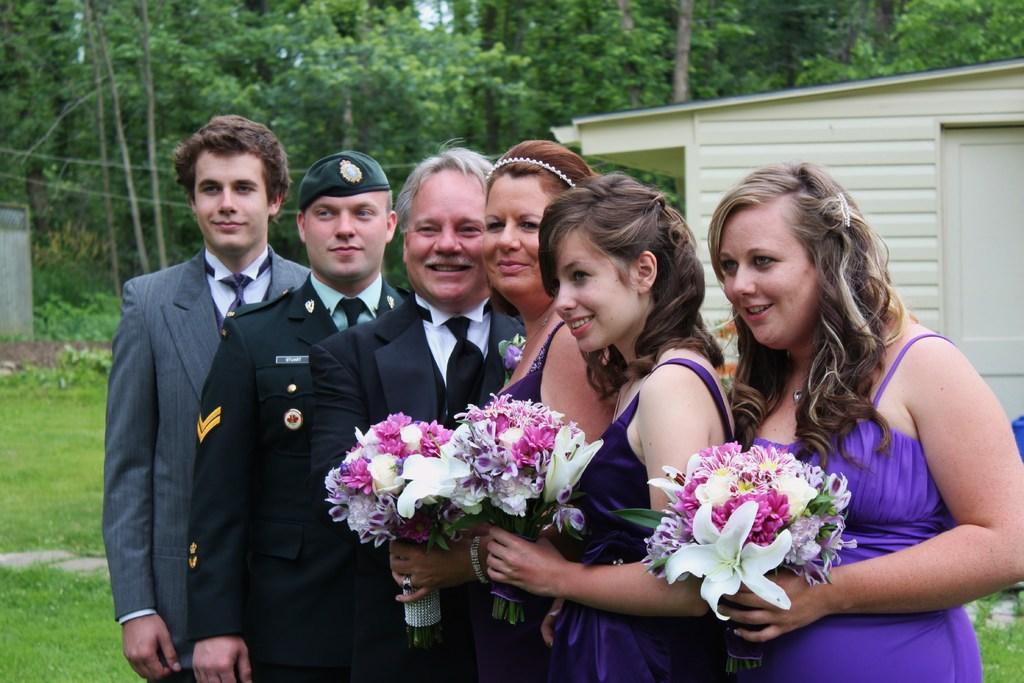In one or two sentences, can you explain what this image depicts? In this image I can see few people with different color dresses. I can see three people are holding the flower bouquets. In the background I can see the house and many trees. 